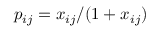Convert formula to latex. <formula><loc_0><loc_0><loc_500><loc_500>p _ { i j } = x _ { i j } / ( 1 + x _ { i j } )</formula> 